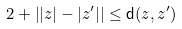<formula> <loc_0><loc_0><loc_500><loc_500>2 + \left | | z | - | z ^ { \prime } | \right | \leq \mathsf d ( z , z ^ { \prime } )</formula> 